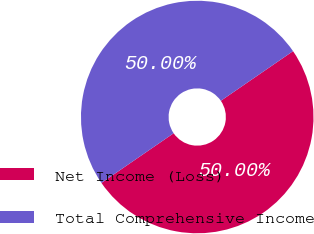Convert chart to OTSL. <chart><loc_0><loc_0><loc_500><loc_500><pie_chart><fcel>Net Income (Loss)<fcel>Total Comprehensive Income<nl><fcel>50.0%<fcel>50.0%<nl></chart> 